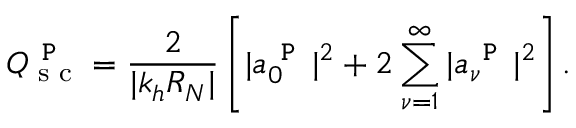<formula> <loc_0><loc_0><loc_500><loc_500>Q _ { s c } ^ { P } = \frac { 2 } { | k _ { h } R _ { N } | } \left [ | a _ { 0 } ^ { P } | ^ { 2 } + 2 \sum _ { \nu = 1 } ^ { \infty } | a _ { \nu } ^ { P } | ^ { 2 } \right ] .</formula> 